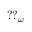<formula> <loc_0><loc_0><loc_500><loc_500>{ ? ? } _ { \omega }</formula> 